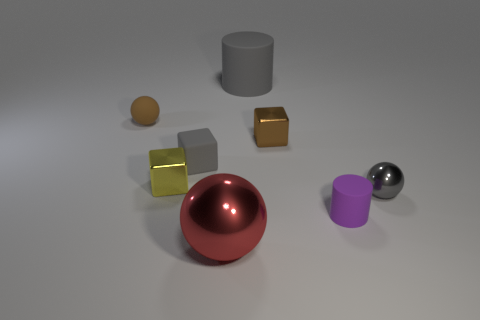Add 2 tiny brown matte things. How many objects exist? 10 Subtract all cylinders. How many objects are left? 6 Add 6 small purple objects. How many small purple objects are left? 7 Add 3 large blue cubes. How many large blue cubes exist? 3 Subtract 1 brown cubes. How many objects are left? 7 Subtract all tiny yellow rubber cylinders. Subtract all large gray matte things. How many objects are left? 7 